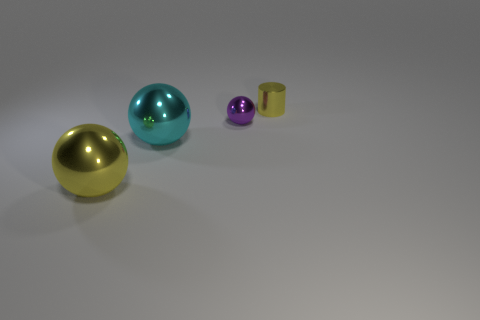Subtract all green cylinders. Subtract all red blocks. How many cylinders are left? 1 Add 1 big yellow metallic spheres. How many objects exist? 5 Subtract all spheres. How many objects are left? 1 Subtract all tiny red metal cylinders. Subtract all large yellow balls. How many objects are left? 3 Add 4 cylinders. How many cylinders are left? 5 Add 2 yellow shiny balls. How many yellow shiny balls exist? 3 Subtract 0 red cylinders. How many objects are left? 4 